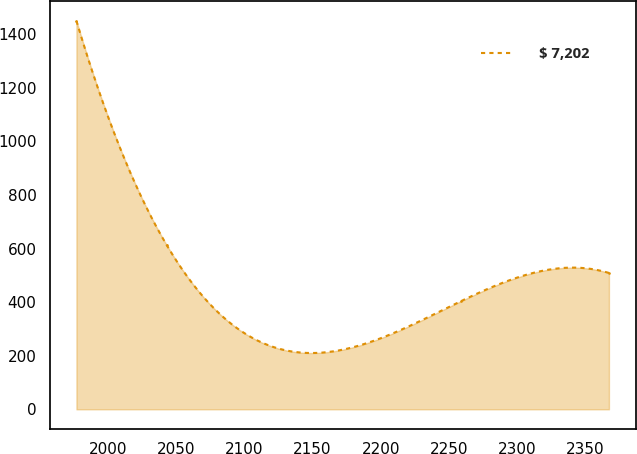Convert chart to OTSL. <chart><loc_0><loc_0><loc_500><loc_500><line_chart><ecel><fcel>$ 7,202<nl><fcel>1976.77<fcel>1450.39<nl><fcel>2042.94<fcel>613.71<nl><fcel>2259.17<fcel>404.53<nl><fcel>2367.49<fcel>509.12<nl></chart> 